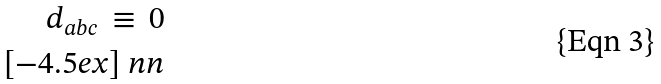Convert formula to latex. <formula><loc_0><loc_0><loc_500><loc_500>d _ { a b c } \, \equiv \, 0 \\ [ - 4 . 5 e x ] \ n n</formula> 